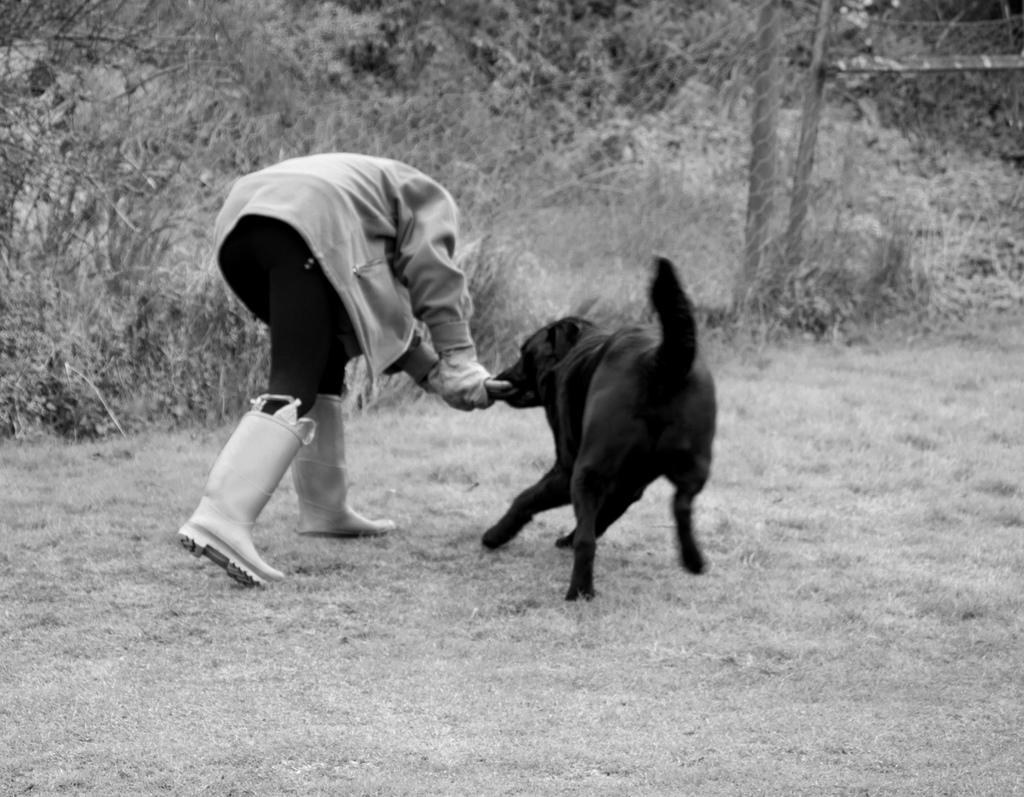What is the color scheme of the image? The image is black and white. What can be seen in the background of the image? There are plants in the background of the image. Who is present in the image? There is a person in the image. What is the person doing in the image? The person is playing with a dog. What is the color of the dog in the image? The dog is black in color. Is the person in the image sleeping under a flesh-colored cover? There is no mention of a person sleeping or a flesh-colored cover in the image; it features a person playing with a black dog in a black and white setting with plants in the background. 